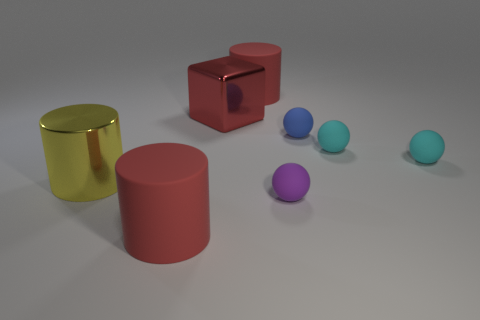There is a red cylinder that is right of the rubber cylinder in front of the matte object that is behind the red metallic cube; what is its size?
Your response must be concise. Large. What material is the purple sphere?
Your response must be concise. Rubber. There is a yellow thing; is it the same shape as the large matte object on the right side of the big shiny block?
Ensure brevity in your answer.  Yes. There is a large cylinder on the left side of the matte object in front of the small purple matte sphere that is on the right side of the yellow metallic object; what is its material?
Your answer should be very brief. Metal. What number of blue objects are there?
Ensure brevity in your answer.  1. What number of blue objects are either big balls or rubber things?
Your response must be concise. 1. What number of other things are there of the same shape as the blue matte thing?
Your answer should be compact. 3. Does the rubber cylinder in front of the blue rubber ball have the same color as the shiny object right of the yellow object?
Provide a short and direct response. Yes. How many small things are red metal things or gray rubber objects?
Your answer should be compact. 0. What is the size of the blue matte thing that is the same shape as the purple matte object?
Make the answer very short. Small. 